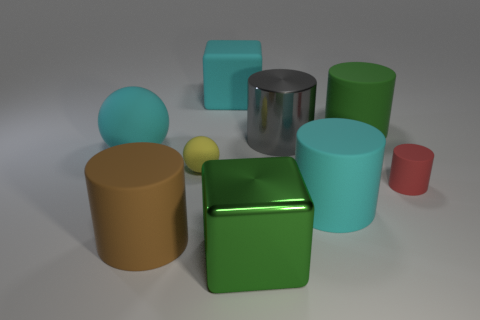There is a green object in front of the big green object right of the object in front of the big brown matte object; how big is it?
Ensure brevity in your answer.  Large. How many matte things are either large green blocks or gray objects?
Your answer should be very brief. 0. There is a brown object; is it the same shape as the tiny thing to the right of the large green metallic block?
Your response must be concise. Yes. Is the number of yellow matte things that are behind the yellow rubber ball greater than the number of big rubber cylinders right of the tiny matte cylinder?
Offer a very short reply. No. Is there any other thing of the same color as the tiny matte sphere?
Ensure brevity in your answer.  No. There is a tiny rubber object that is on the right side of the metal thing that is behind the large brown object; are there any large rubber cubes that are on the left side of it?
Offer a terse response. Yes. Is the shape of the small matte thing that is to the left of the big green metallic block the same as  the green matte object?
Your answer should be compact. No. Are there fewer large brown cylinders that are behind the large green rubber thing than tiny yellow rubber spheres that are behind the yellow object?
Offer a very short reply. No. What is the material of the tiny cylinder?
Make the answer very short. Rubber. Do the large ball and the small matte object left of the big green metal cube have the same color?
Give a very brief answer. No. 